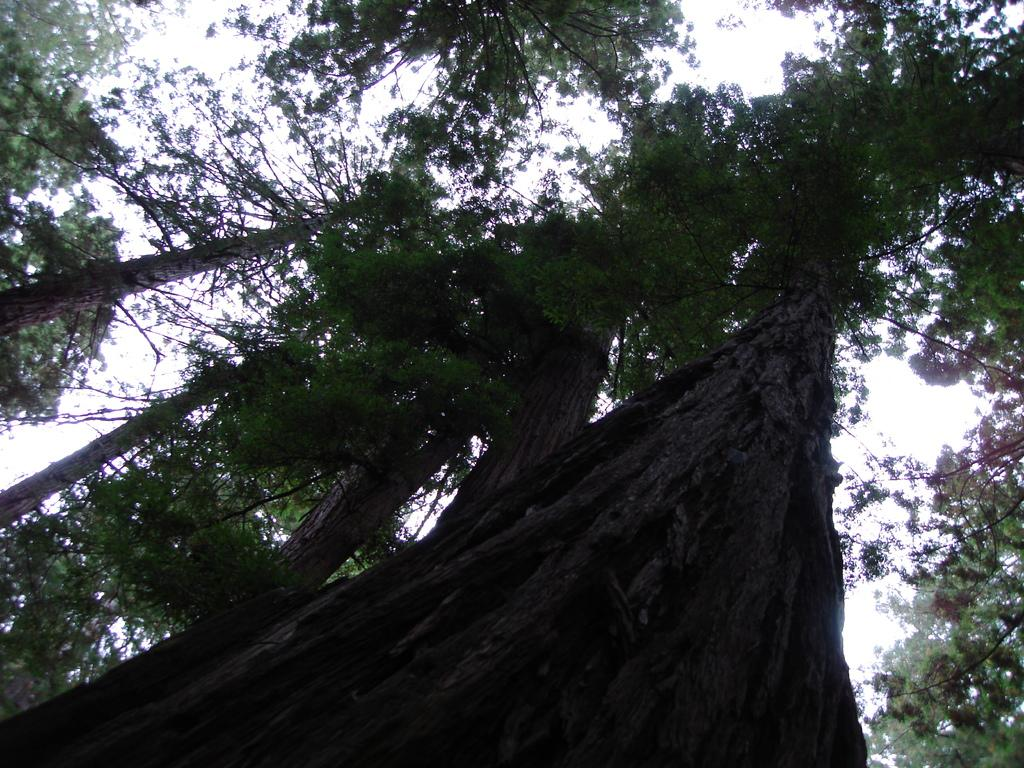What type of vegetation can be seen in the image? There are trees in the image. What is the value of the haircut depicted in the image? There is no haircut present in the image, as it only features trees. What beliefs are represented by the trees in the image? The image does not depict any beliefs; it simply shows trees. 